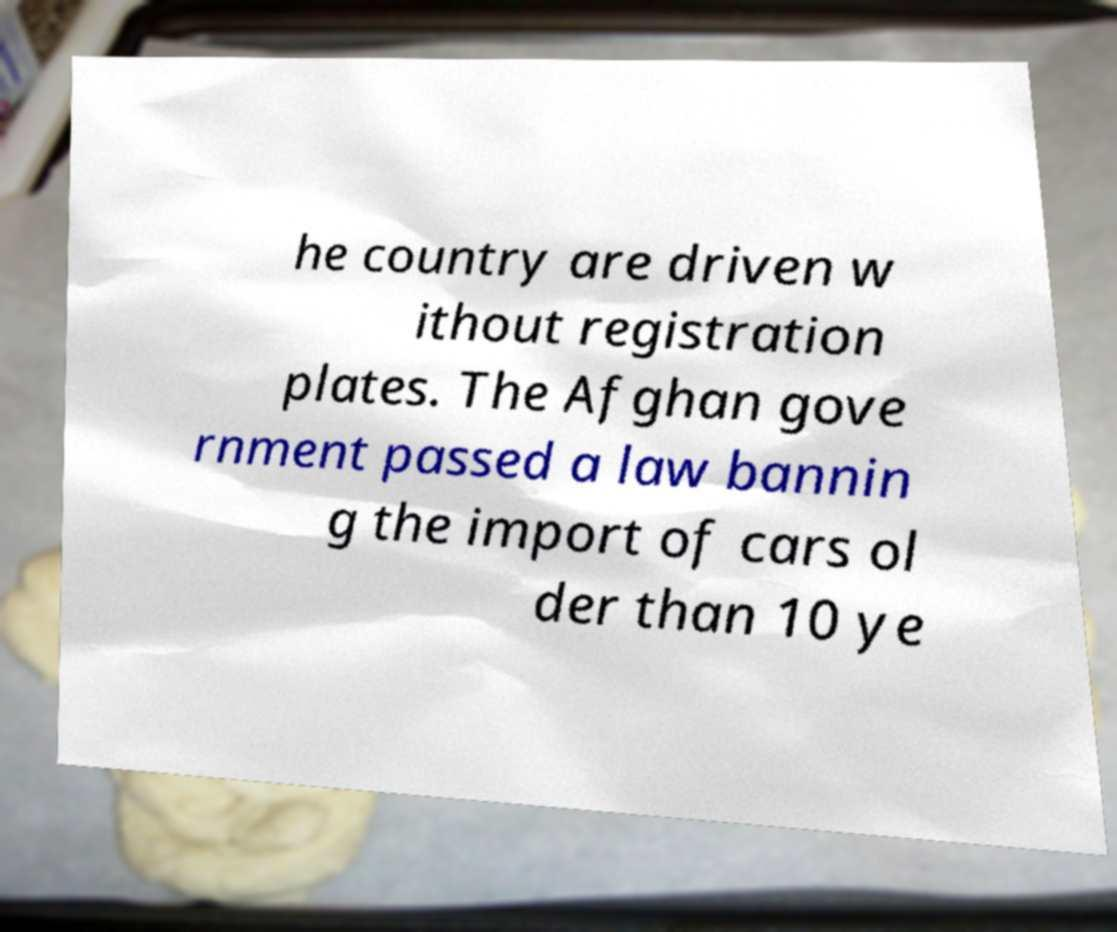I need the written content from this picture converted into text. Can you do that? he country are driven w ithout registration plates. The Afghan gove rnment passed a law bannin g the import of cars ol der than 10 ye 